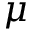<formula> <loc_0><loc_0><loc_500><loc_500>\mu</formula> 